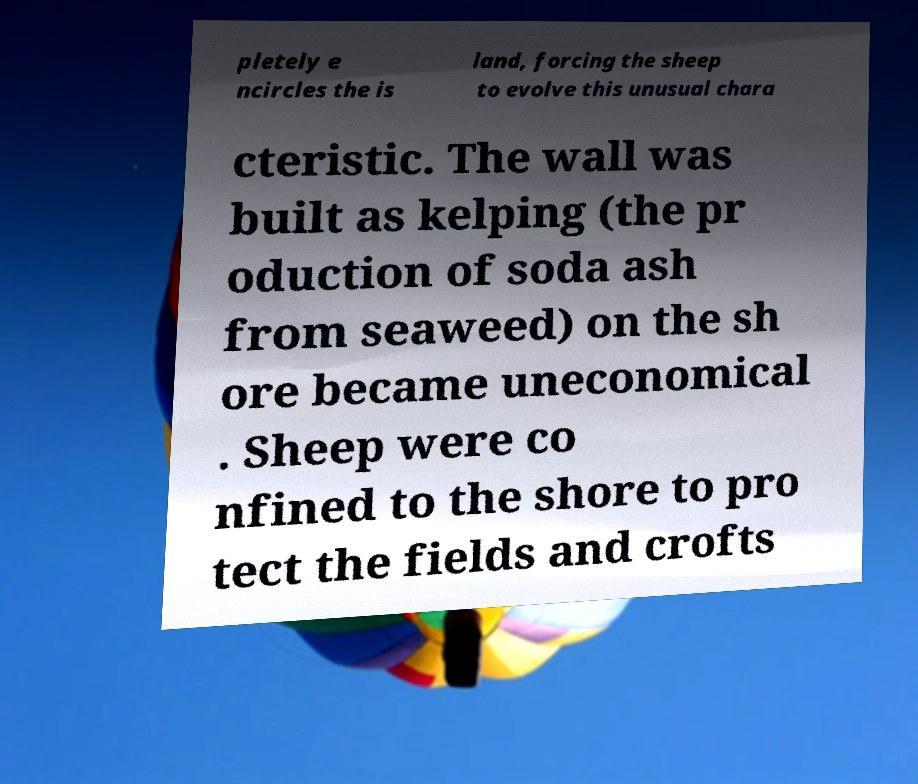Can you read and provide the text displayed in the image?This photo seems to have some interesting text. Can you extract and type it out for me? pletely e ncircles the is land, forcing the sheep to evolve this unusual chara cteristic. The wall was built as kelping (the pr oduction of soda ash from seaweed) on the sh ore became uneconomical . Sheep were co nfined to the shore to pro tect the fields and crofts 